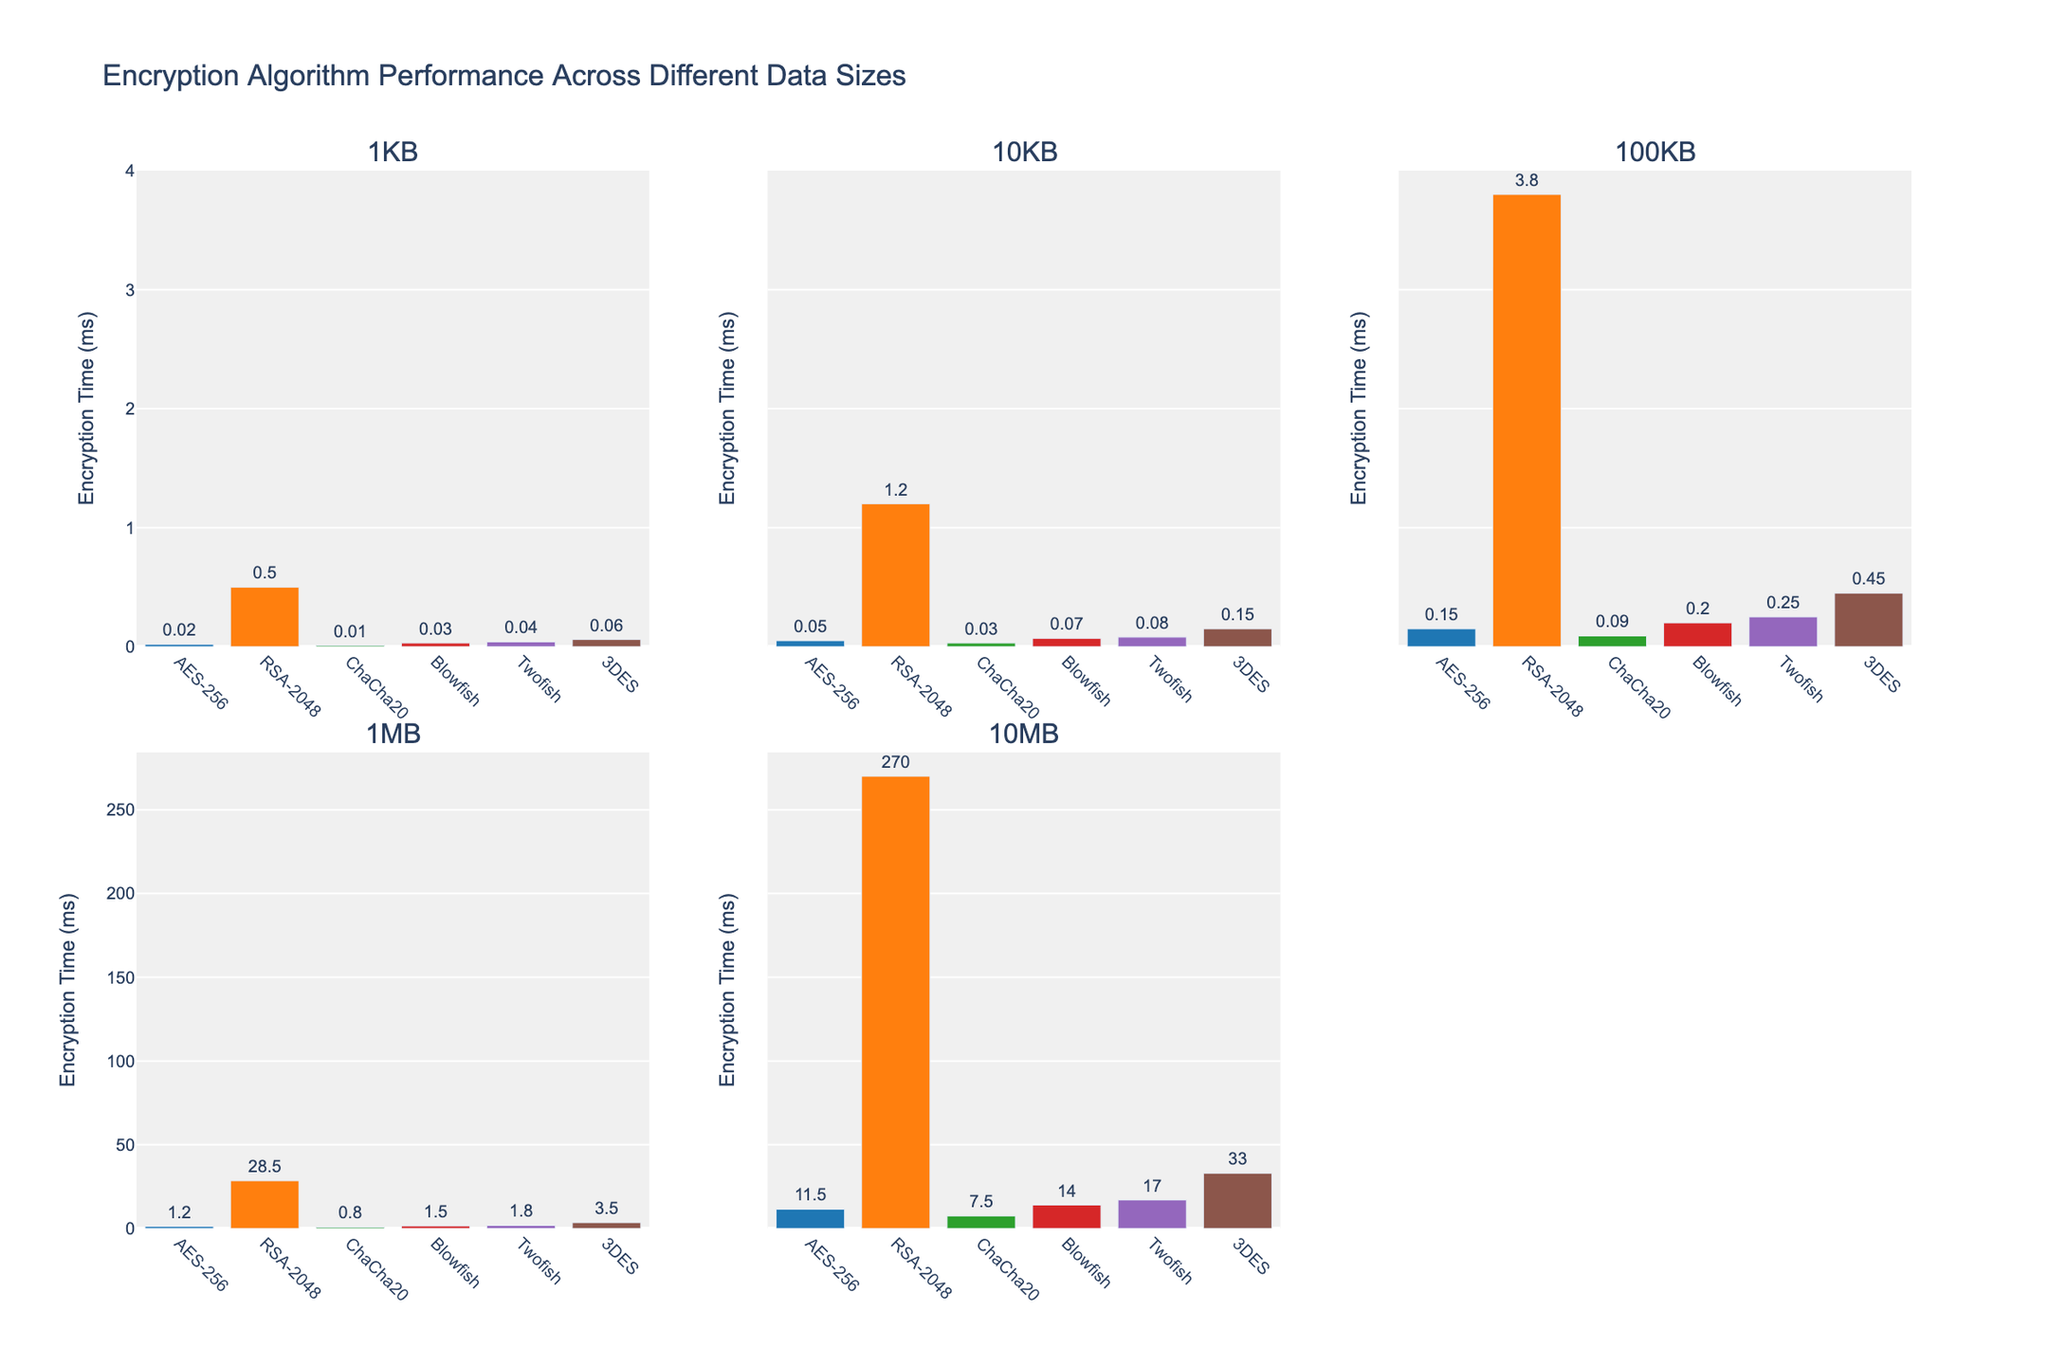Which algorithm has the highest encryption time for 10MB? Look at the bar heights for the 10MB subplot and identify the tallest bar. The tallest bar represents RSA-2048.
Answer: RSA-2048 What is the approximate encryption time of AES-256 for 1KB and 10KB? Look at the AES-256 bars for the 1KB and 10KB subplots and read the values above the bars, which are 0.02 ms and 0.05 ms respectively.
Answer: 0.02 ms and 0.05 ms Calculate the difference in encryption times between Twofish and Blowfish for 1MB. First identify and read the values for Twofish and Blowfish in the 1MB subplot, which are 1.8 ms and 1.5 ms respectively. Subtract the smaller value from the larger value: 1.8 - 1.5 = 0.3 ms.
Answer: 0.3 ms Which algorithm shows the lowest encryption time consistently across all data sizes? Compare the bars for each algorithm in all subplots. ChaCha20 consistently has the shortest bars in all subplots, indicating the lowest encryption times.
Answer: ChaCha20 Between AES-256 and 3DES algorithms, which one has lower encryption time for 100KB data size and by how much? Identify the bars for AES-256 and 3DES in the 100KB subplot and read their values, which are 0.15 ms and 0.45 ms respectively. Subtract the AES-256 encryption time from 3DES encryption time: 0.45 - 0.15 = 0.3 ms.
Answer: AES-256 by 0.3 ms For the 10MB data size, which two algorithms have the closest encryption times? Examine the heights of the bars for each algorithm in the 10MB subplot and find the two bars that are closest in height. Blowfish and Twofish have close values of 14.0 ms and 17.0 ms respectively, with a difference of just 3 ms.
Answer: Blowfish and Twofish What is the sum of encryption times for Blowfish across all data sizes? Add the values for Blowfish from all subplots: 0.03 (1KB) + 0.07 (10KB) + 0.2 (100KB) + 1.5 (1MB) + 14.0 (10MB) = 15.8 ms.
Answer: 15.8 ms Which row of subplots contains the larger encryption times overall? Compare the general bar heights in both rows. The second row (1MB, 10MB) contains generally larger encryption times compared to the first row (1KB, 10KB, 100KB).
Answer: Second row By how much does the encryption time of 3DES increase from 1KB to 10MB? Identify the encryption time values for 3DES in the 1KB and 10MB subplots, which are 0.06 ms and 33.0 ms respectively. Subtract the 1KB value from the 10MB value: 33.0 - 0.06 = 32.94 ms.
Answer: 32.94 ms Which encryption algorithm shows the steepest increase in encryption time with increasing data size? Compare the slope of the bars for each algorithm across all subplots. RSA-2048 shows the steepest increase, with encryption times jumping significantly from smaller to larger data sizes.
Answer: RSA-2048 